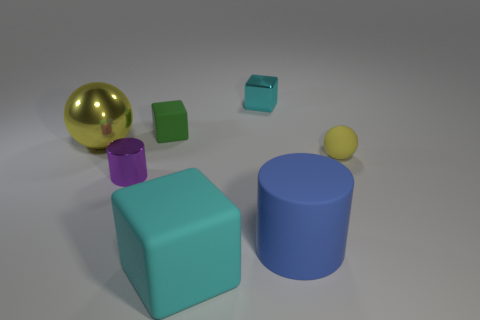Add 3 cylinders. How many objects exist? 10 Subtract all balls. How many objects are left? 5 Add 5 tiny cyan cubes. How many tiny cyan cubes exist? 6 Subtract 0 brown blocks. How many objects are left? 7 Subtract all small cylinders. Subtract all small spheres. How many objects are left? 5 Add 6 tiny blocks. How many tiny blocks are left? 8 